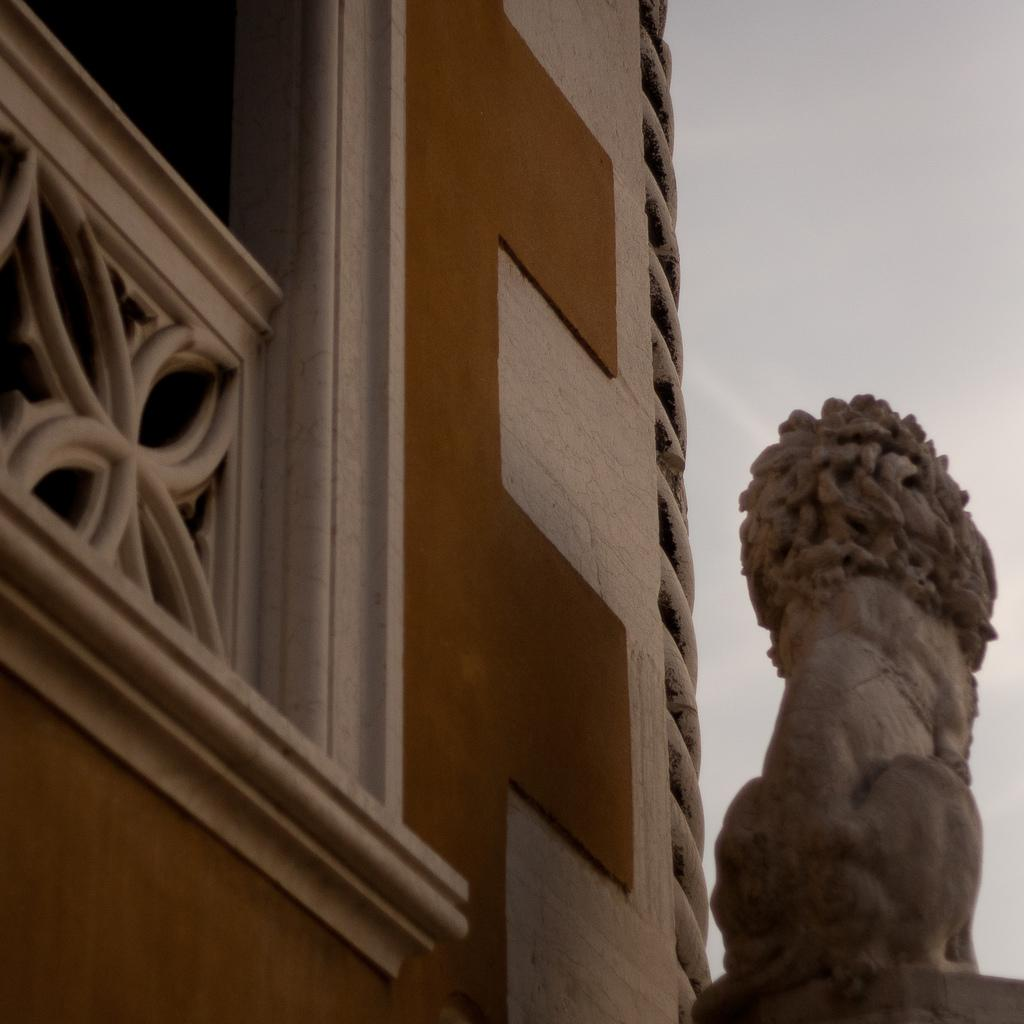What type of structure is present in the image? There is a building in the image. What artistic element can be seen in the image? There is a sculpture in the image. What can be seen in the distance in the image? The sky is visible in the background of the image. What type of alarm is ringing in the image? There is no alarm present in the image. What type of pocket can be seen on the building in the image? There is no pocket visible on the building in the image. 